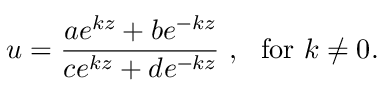Convert formula to latex. <formula><loc_0><loc_0><loc_500><loc_500>u = \frac { a e ^ { k z } + b e ^ { - k z } } { c e ^ { k z } + d e ^ { - k z } } , f o r k \neq 0 .</formula> 